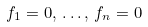<formula> <loc_0><loc_0><loc_500><loc_500>f _ { 1 } = 0 , \, \dots , \, f _ { n } = 0</formula> 